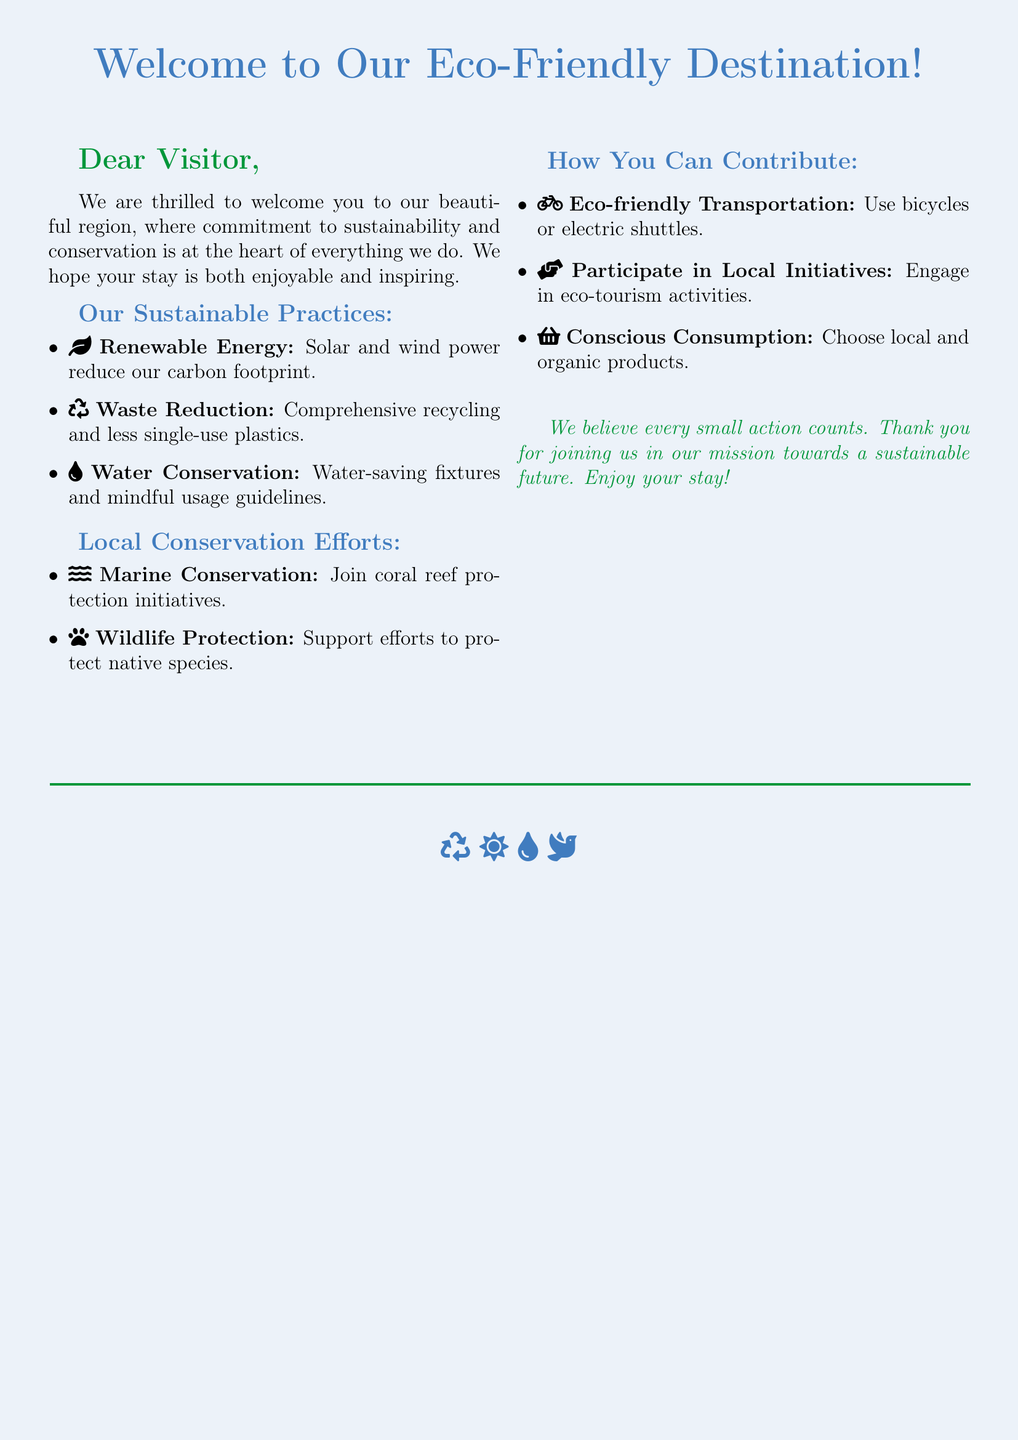what is the main theme of the card? The main theme is the commitment to sustainability and conservation in the region.
Answer: sustainability and conservation what are the three sustainable practices mentioned? The card lists specific sustainable practices such as renewable energy, waste reduction, and water conservation.
Answer: renewable energy, waste reduction, water conservation how can visitors contribute to local conservation efforts? The document outlines ways visitors can contribute, like participating in local initiatives.
Answer: participate in local initiatives what icon represents wildlife protection? The card uses an icon to represent wildlife protection initiatives as part of local conservation efforts.
Answer: paw which color is primarily used in the greeting card? The card prominently features the color associated with eco-friendliness, which sets its tone.
Answer: ecoblue name one eco-friendly form of transportation mentioned. The card suggests ways for eco-friendly transportation, specifically highlighting bicycles or electric shuttles as options.
Answer: bicycles what message is conveyed at the end of the card? The concluding statement emphasizes the importance of collective small actions for sustainability and welcomes the guest.
Answer: every small action counts how many local conservation efforts are highlighted? The document enumerates specific local conservation efforts to help visitors understand the initiatives taking place.
Answer: two 